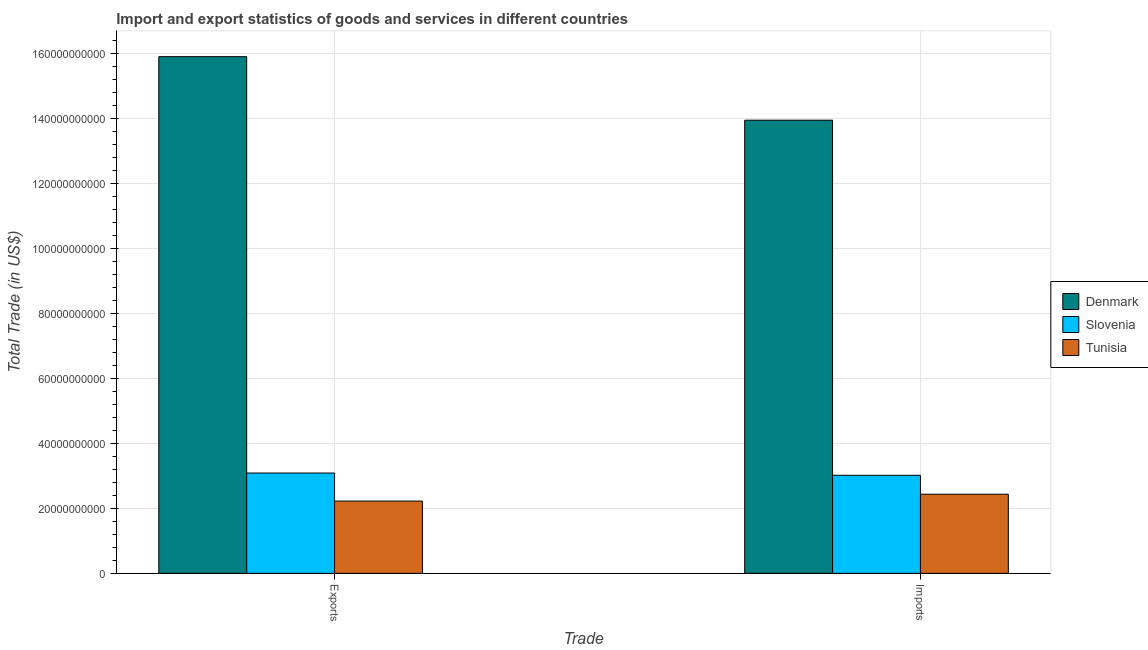Are the number of bars per tick equal to the number of legend labels?
Your answer should be compact. Yes. How many bars are there on the 2nd tick from the left?
Keep it short and to the point. 3. How many bars are there on the 1st tick from the right?
Your response must be concise. 3. What is the label of the 2nd group of bars from the left?
Your answer should be compact. Imports. What is the export of goods and services in Tunisia?
Your answer should be compact. 2.22e+1. Across all countries, what is the maximum imports of goods and services?
Make the answer very short. 1.39e+11. Across all countries, what is the minimum export of goods and services?
Your answer should be compact. 2.22e+1. In which country was the imports of goods and services maximum?
Keep it short and to the point. Denmark. In which country was the imports of goods and services minimum?
Keep it short and to the point. Tunisia. What is the total imports of goods and services in the graph?
Give a very brief answer. 1.94e+11. What is the difference between the imports of goods and services in Tunisia and that in Denmark?
Give a very brief answer. -1.15e+11. What is the difference between the imports of goods and services in Denmark and the export of goods and services in Tunisia?
Offer a terse response. 1.17e+11. What is the average export of goods and services per country?
Give a very brief answer. 7.07e+1. What is the difference between the imports of goods and services and export of goods and services in Tunisia?
Your answer should be compact. 2.11e+09. What is the ratio of the export of goods and services in Denmark to that in Tunisia?
Your answer should be compact. 7.15. Is the imports of goods and services in Tunisia less than that in Slovenia?
Your answer should be compact. Yes. In how many countries, is the imports of goods and services greater than the average imports of goods and services taken over all countries?
Provide a short and direct response. 1. What does the 3rd bar from the left in Imports represents?
Your answer should be very brief. Tunisia. What does the 1st bar from the right in Imports represents?
Give a very brief answer. Tunisia. How many bars are there?
Provide a short and direct response. 6. Are all the bars in the graph horizontal?
Give a very brief answer. No. How many countries are there in the graph?
Provide a short and direct response. 3. What is the difference between two consecutive major ticks on the Y-axis?
Your answer should be very brief. 2.00e+1. Are the values on the major ticks of Y-axis written in scientific E-notation?
Your answer should be very brief. No. How many legend labels are there?
Give a very brief answer. 3. What is the title of the graph?
Your answer should be compact. Import and export statistics of goods and services in different countries. What is the label or title of the X-axis?
Ensure brevity in your answer.  Trade. What is the label or title of the Y-axis?
Offer a terse response. Total Trade (in US$). What is the Total Trade (in US$) of Denmark in Exports?
Your answer should be compact. 1.59e+11. What is the Total Trade (in US$) in Slovenia in Exports?
Provide a succinct answer. 3.09e+1. What is the Total Trade (in US$) of Tunisia in Exports?
Make the answer very short. 2.22e+1. What is the Total Trade (in US$) in Denmark in Imports?
Keep it short and to the point. 1.39e+11. What is the Total Trade (in US$) of Slovenia in Imports?
Provide a succinct answer. 3.02e+1. What is the Total Trade (in US$) of Tunisia in Imports?
Make the answer very short. 2.44e+1. Across all Trade, what is the maximum Total Trade (in US$) of Denmark?
Keep it short and to the point. 1.59e+11. Across all Trade, what is the maximum Total Trade (in US$) of Slovenia?
Keep it short and to the point. 3.09e+1. Across all Trade, what is the maximum Total Trade (in US$) in Tunisia?
Offer a terse response. 2.44e+1. Across all Trade, what is the minimum Total Trade (in US$) in Denmark?
Your answer should be compact. 1.39e+11. Across all Trade, what is the minimum Total Trade (in US$) of Slovenia?
Make the answer very short. 3.02e+1. Across all Trade, what is the minimum Total Trade (in US$) of Tunisia?
Your answer should be very brief. 2.22e+1. What is the total Total Trade (in US$) in Denmark in the graph?
Give a very brief answer. 2.98e+11. What is the total Total Trade (in US$) of Slovenia in the graph?
Make the answer very short. 6.10e+1. What is the total Total Trade (in US$) of Tunisia in the graph?
Keep it short and to the point. 4.66e+1. What is the difference between the Total Trade (in US$) in Denmark in Exports and that in Imports?
Your response must be concise. 1.96e+1. What is the difference between the Total Trade (in US$) of Slovenia in Exports and that in Imports?
Give a very brief answer. 6.89e+08. What is the difference between the Total Trade (in US$) of Tunisia in Exports and that in Imports?
Provide a succinct answer. -2.11e+09. What is the difference between the Total Trade (in US$) of Denmark in Exports and the Total Trade (in US$) of Slovenia in Imports?
Your answer should be very brief. 1.29e+11. What is the difference between the Total Trade (in US$) in Denmark in Exports and the Total Trade (in US$) in Tunisia in Imports?
Provide a succinct answer. 1.35e+11. What is the difference between the Total Trade (in US$) of Slovenia in Exports and the Total Trade (in US$) of Tunisia in Imports?
Your response must be concise. 6.52e+09. What is the average Total Trade (in US$) in Denmark per Trade?
Provide a short and direct response. 1.49e+11. What is the average Total Trade (in US$) of Slovenia per Trade?
Your answer should be compact. 3.05e+1. What is the average Total Trade (in US$) of Tunisia per Trade?
Make the answer very short. 2.33e+1. What is the difference between the Total Trade (in US$) of Denmark and Total Trade (in US$) of Slovenia in Exports?
Give a very brief answer. 1.28e+11. What is the difference between the Total Trade (in US$) in Denmark and Total Trade (in US$) in Tunisia in Exports?
Offer a very short reply. 1.37e+11. What is the difference between the Total Trade (in US$) in Slovenia and Total Trade (in US$) in Tunisia in Exports?
Make the answer very short. 8.63e+09. What is the difference between the Total Trade (in US$) in Denmark and Total Trade (in US$) in Slovenia in Imports?
Keep it short and to the point. 1.09e+11. What is the difference between the Total Trade (in US$) of Denmark and Total Trade (in US$) of Tunisia in Imports?
Keep it short and to the point. 1.15e+11. What is the difference between the Total Trade (in US$) in Slovenia and Total Trade (in US$) in Tunisia in Imports?
Your answer should be compact. 5.83e+09. What is the ratio of the Total Trade (in US$) of Denmark in Exports to that in Imports?
Your answer should be compact. 1.14. What is the ratio of the Total Trade (in US$) of Slovenia in Exports to that in Imports?
Provide a succinct answer. 1.02. What is the ratio of the Total Trade (in US$) in Tunisia in Exports to that in Imports?
Your response must be concise. 0.91. What is the difference between the highest and the second highest Total Trade (in US$) in Denmark?
Make the answer very short. 1.96e+1. What is the difference between the highest and the second highest Total Trade (in US$) in Slovenia?
Ensure brevity in your answer.  6.89e+08. What is the difference between the highest and the second highest Total Trade (in US$) in Tunisia?
Keep it short and to the point. 2.11e+09. What is the difference between the highest and the lowest Total Trade (in US$) in Denmark?
Keep it short and to the point. 1.96e+1. What is the difference between the highest and the lowest Total Trade (in US$) of Slovenia?
Make the answer very short. 6.89e+08. What is the difference between the highest and the lowest Total Trade (in US$) in Tunisia?
Make the answer very short. 2.11e+09. 